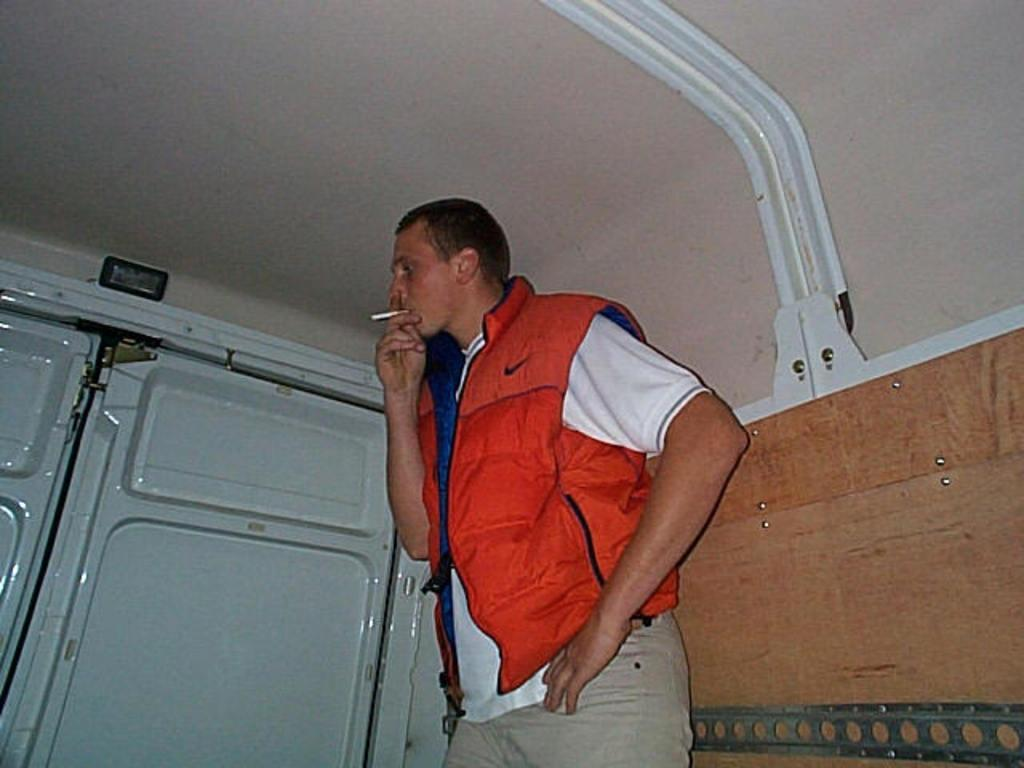Who is present in the image? There is a man in the image. What is the man doing in the image? The man is standing in the image. What is the man wearing in the image? The man is wearing an orange jacket in the image. What activity is the man engaged in? The man is smoking in the image. What can be seen near the man in the image? There is a white door beside the man in the image. What type of vegetable is the man eating in the image? There is no vegetable present in the image; the man is smoking. What role does the governor play in the image? There is no governor present in the image. 